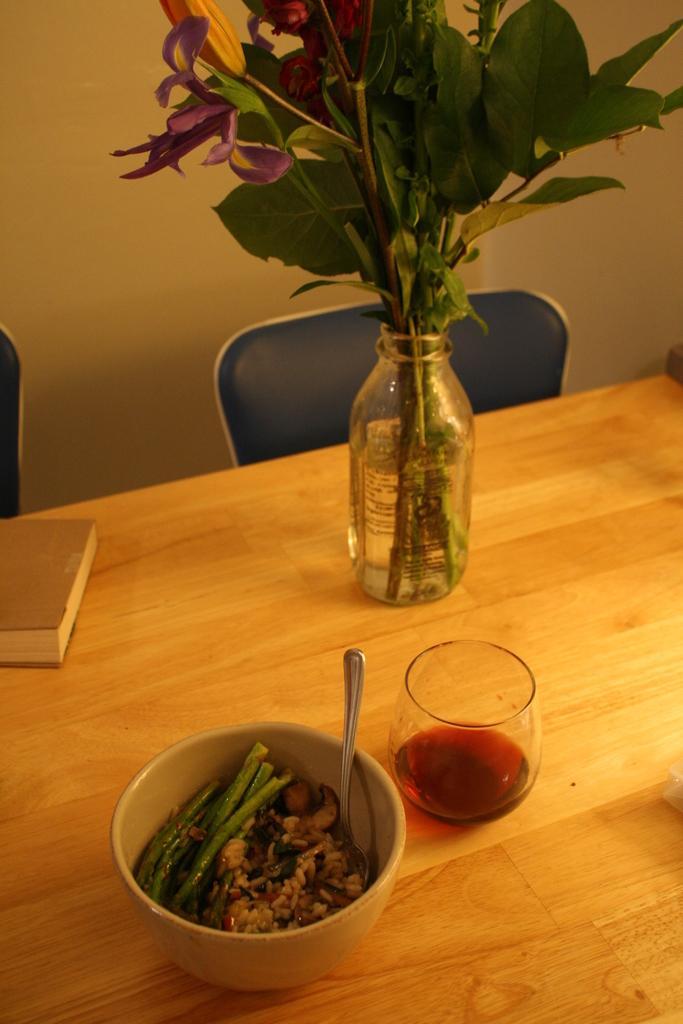In one or two sentences, can you explain what this image depicts? On the table I can see the glass, plants, book, bowl and wine glass. In that bowl I can see the rice and other food item. Beside the table I can see the chair which are placed near to the wall. 